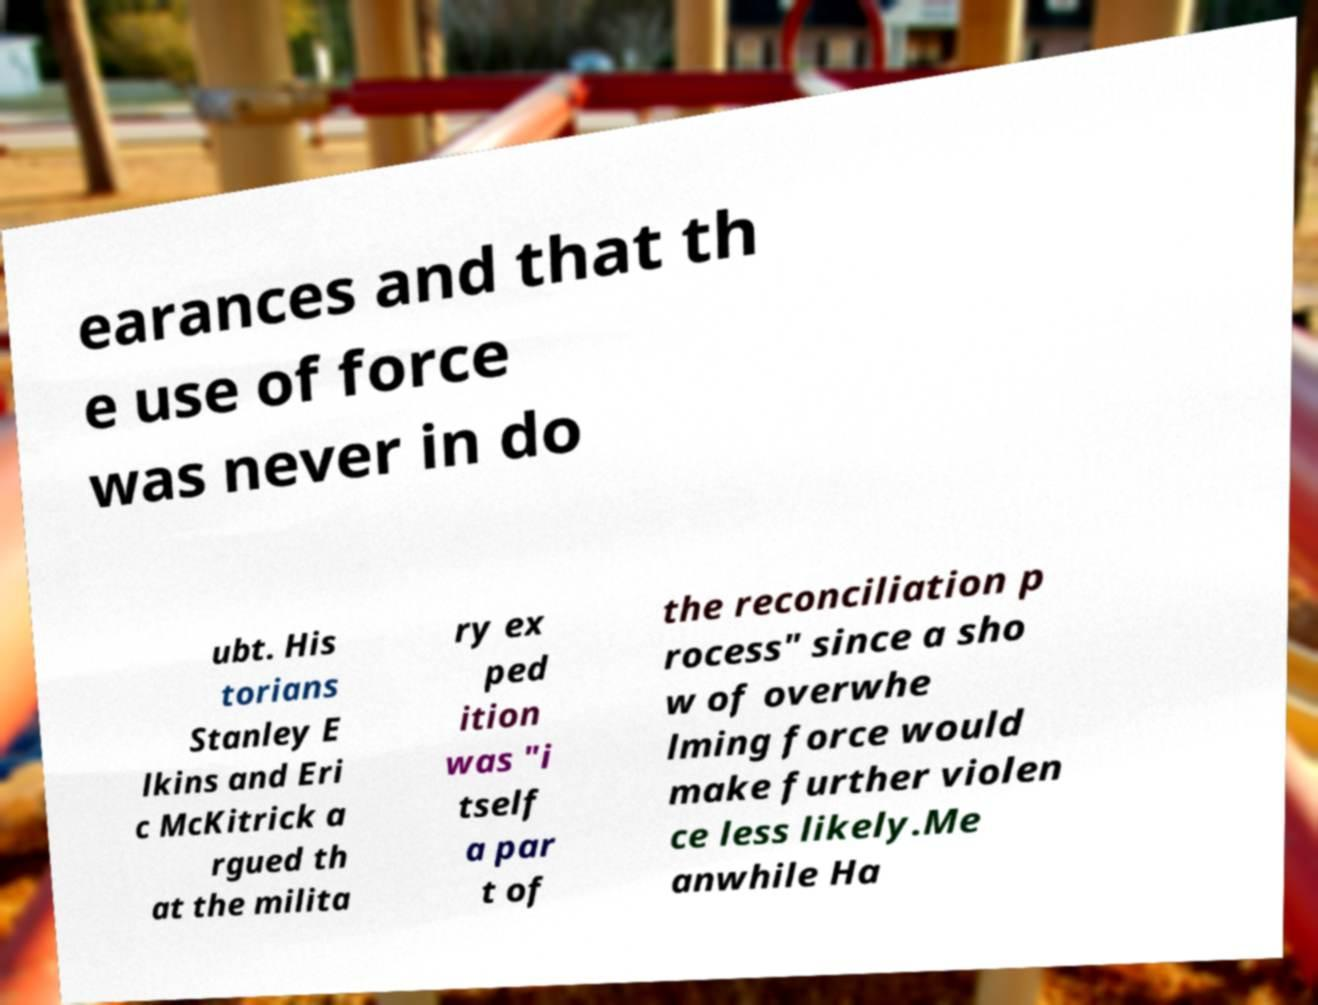Can you read and provide the text displayed in the image?This photo seems to have some interesting text. Can you extract and type it out for me? earances and that th e use of force was never in do ubt. His torians Stanley E lkins and Eri c McKitrick a rgued th at the milita ry ex ped ition was "i tself a par t of the reconciliation p rocess" since a sho w of overwhe lming force would make further violen ce less likely.Me anwhile Ha 